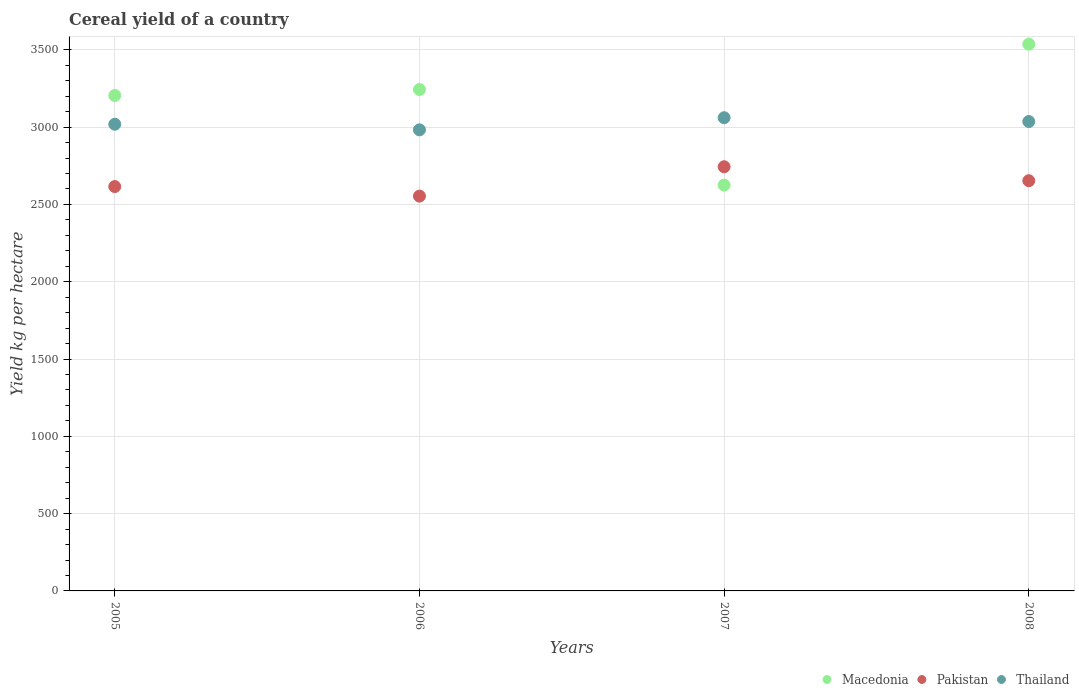How many different coloured dotlines are there?
Offer a very short reply. 3. Is the number of dotlines equal to the number of legend labels?
Provide a succinct answer. Yes. What is the total cereal yield in Thailand in 2008?
Your answer should be very brief. 3036.48. Across all years, what is the maximum total cereal yield in Pakistan?
Make the answer very short. 2743.98. Across all years, what is the minimum total cereal yield in Pakistan?
Provide a short and direct response. 2553.97. In which year was the total cereal yield in Thailand minimum?
Offer a terse response. 2006. What is the total total cereal yield in Macedonia in the graph?
Provide a succinct answer. 1.26e+04. What is the difference between the total cereal yield in Macedonia in 2005 and that in 2007?
Provide a short and direct response. 579.82. What is the difference between the total cereal yield in Pakistan in 2006 and the total cereal yield in Macedonia in 2005?
Provide a succinct answer. -651.06. What is the average total cereal yield in Thailand per year?
Make the answer very short. 3024.8. In the year 2007, what is the difference between the total cereal yield in Macedonia and total cereal yield in Pakistan?
Your response must be concise. -118.77. What is the ratio of the total cereal yield in Macedonia in 2007 to that in 2008?
Your response must be concise. 0.74. Is the total cereal yield in Pakistan in 2007 less than that in 2008?
Provide a short and direct response. No. What is the difference between the highest and the second highest total cereal yield in Thailand?
Your response must be concise. 24.66. What is the difference between the highest and the lowest total cereal yield in Pakistan?
Ensure brevity in your answer.  190.01. In how many years, is the total cereal yield in Macedonia greater than the average total cereal yield in Macedonia taken over all years?
Keep it short and to the point. 3. Is it the case that in every year, the sum of the total cereal yield in Pakistan and total cereal yield in Macedonia  is greater than the total cereal yield in Thailand?
Keep it short and to the point. Yes. Does the total cereal yield in Macedonia monotonically increase over the years?
Give a very brief answer. No. Is the total cereal yield in Thailand strictly greater than the total cereal yield in Macedonia over the years?
Your response must be concise. No. How many dotlines are there?
Offer a terse response. 3. How many years are there in the graph?
Keep it short and to the point. 4. What is the difference between two consecutive major ticks on the Y-axis?
Your answer should be compact. 500. Where does the legend appear in the graph?
Your answer should be very brief. Bottom right. How are the legend labels stacked?
Make the answer very short. Horizontal. What is the title of the graph?
Ensure brevity in your answer.  Cereal yield of a country. Does "Nicaragua" appear as one of the legend labels in the graph?
Your response must be concise. No. What is the label or title of the X-axis?
Your answer should be very brief. Years. What is the label or title of the Y-axis?
Make the answer very short. Yield kg per hectare. What is the Yield kg per hectare of Macedonia in 2005?
Offer a terse response. 3205.03. What is the Yield kg per hectare in Pakistan in 2005?
Offer a terse response. 2615.79. What is the Yield kg per hectare in Thailand in 2005?
Your response must be concise. 3018.89. What is the Yield kg per hectare of Macedonia in 2006?
Your answer should be very brief. 3243.51. What is the Yield kg per hectare of Pakistan in 2006?
Provide a short and direct response. 2553.97. What is the Yield kg per hectare in Thailand in 2006?
Make the answer very short. 2982.71. What is the Yield kg per hectare of Macedonia in 2007?
Provide a short and direct response. 2625.21. What is the Yield kg per hectare of Pakistan in 2007?
Your response must be concise. 2743.98. What is the Yield kg per hectare of Thailand in 2007?
Give a very brief answer. 3061.14. What is the Yield kg per hectare of Macedonia in 2008?
Your answer should be compact. 3536.86. What is the Yield kg per hectare in Pakistan in 2008?
Offer a very short reply. 2653.72. What is the Yield kg per hectare in Thailand in 2008?
Ensure brevity in your answer.  3036.48. Across all years, what is the maximum Yield kg per hectare of Macedonia?
Provide a short and direct response. 3536.86. Across all years, what is the maximum Yield kg per hectare of Pakistan?
Make the answer very short. 2743.98. Across all years, what is the maximum Yield kg per hectare of Thailand?
Give a very brief answer. 3061.14. Across all years, what is the minimum Yield kg per hectare in Macedonia?
Give a very brief answer. 2625.21. Across all years, what is the minimum Yield kg per hectare in Pakistan?
Keep it short and to the point. 2553.97. Across all years, what is the minimum Yield kg per hectare in Thailand?
Your answer should be very brief. 2982.71. What is the total Yield kg per hectare in Macedonia in the graph?
Give a very brief answer. 1.26e+04. What is the total Yield kg per hectare in Pakistan in the graph?
Your answer should be compact. 1.06e+04. What is the total Yield kg per hectare in Thailand in the graph?
Offer a terse response. 1.21e+04. What is the difference between the Yield kg per hectare of Macedonia in 2005 and that in 2006?
Your answer should be very brief. -38.48. What is the difference between the Yield kg per hectare of Pakistan in 2005 and that in 2006?
Keep it short and to the point. 61.83. What is the difference between the Yield kg per hectare of Thailand in 2005 and that in 2006?
Your answer should be compact. 36.18. What is the difference between the Yield kg per hectare in Macedonia in 2005 and that in 2007?
Provide a short and direct response. 579.82. What is the difference between the Yield kg per hectare of Pakistan in 2005 and that in 2007?
Make the answer very short. -128.19. What is the difference between the Yield kg per hectare of Thailand in 2005 and that in 2007?
Ensure brevity in your answer.  -42.24. What is the difference between the Yield kg per hectare of Macedonia in 2005 and that in 2008?
Provide a short and direct response. -331.83. What is the difference between the Yield kg per hectare of Pakistan in 2005 and that in 2008?
Ensure brevity in your answer.  -37.93. What is the difference between the Yield kg per hectare of Thailand in 2005 and that in 2008?
Make the answer very short. -17.59. What is the difference between the Yield kg per hectare in Macedonia in 2006 and that in 2007?
Offer a very short reply. 618.3. What is the difference between the Yield kg per hectare of Pakistan in 2006 and that in 2007?
Your response must be concise. -190.01. What is the difference between the Yield kg per hectare of Thailand in 2006 and that in 2007?
Offer a very short reply. -78.42. What is the difference between the Yield kg per hectare of Macedonia in 2006 and that in 2008?
Make the answer very short. -293.35. What is the difference between the Yield kg per hectare of Pakistan in 2006 and that in 2008?
Offer a terse response. -99.76. What is the difference between the Yield kg per hectare of Thailand in 2006 and that in 2008?
Provide a short and direct response. -53.77. What is the difference between the Yield kg per hectare of Macedonia in 2007 and that in 2008?
Your response must be concise. -911.65. What is the difference between the Yield kg per hectare of Pakistan in 2007 and that in 2008?
Make the answer very short. 90.26. What is the difference between the Yield kg per hectare in Thailand in 2007 and that in 2008?
Offer a very short reply. 24.66. What is the difference between the Yield kg per hectare in Macedonia in 2005 and the Yield kg per hectare in Pakistan in 2006?
Your answer should be compact. 651.06. What is the difference between the Yield kg per hectare in Macedonia in 2005 and the Yield kg per hectare in Thailand in 2006?
Make the answer very short. 222.31. What is the difference between the Yield kg per hectare in Pakistan in 2005 and the Yield kg per hectare in Thailand in 2006?
Provide a succinct answer. -366.92. What is the difference between the Yield kg per hectare of Macedonia in 2005 and the Yield kg per hectare of Pakistan in 2007?
Your response must be concise. 461.05. What is the difference between the Yield kg per hectare of Macedonia in 2005 and the Yield kg per hectare of Thailand in 2007?
Make the answer very short. 143.89. What is the difference between the Yield kg per hectare of Pakistan in 2005 and the Yield kg per hectare of Thailand in 2007?
Offer a very short reply. -445.34. What is the difference between the Yield kg per hectare in Macedonia in 2005 and the Yield kg per hectare in Pakistan in 2008?
Give a very brief answer. 551.3. What is the difference between the Yield kg per hectare in Macedonia in 2005 and the Yield kg per hectare in Thailand in 2008?
Provide a short and direct response. 168.55. What is the difference between the Yield kg per hectare in Pakistan in 2005 and the Yield kg per hectare in Thailand in 2008?
Give a very brief answer. -420.68. What is the difference between the Yield kg per hectare of Macedonia in 2006 and the Yield kg per hectare of Pakistan in 2007?
Your answer should be very brief. 499.53. What is the difference between the Yield kg per hectare of Macedonia in 2006 and the Yield kg per hectare of Thailand in 2007?
Offer a very short reply. 182.38. What is the difference between the Yield kg per hectare of Pakistan in 2006 and the Yield kg per hectare of Thailand in 2007?
Your response must be concise. -507.17. What is the difference between the Yield kg per hectare in Macedonia in 2006 and the Yield kg per hectare in Pakistan in 2008?
Make the answer very short. 589.79. What is the difference between the Yield kg per hectare in Macedonia in 2006 and the Yield kg per hectare in Thailand in 2008?
Your answer should be compact. 207.03. What is the difference between the Yield kg per hectare in Pakistan in 2006 and the Yield kg per hectare in Thailand in 2008?
Your response must be concise. -482.51. What is the difference between the Yield kg per hectare in Macedonia in 2007 and the Yield kg per hectare in Pakistan in 2008?
Offer a very short reply. -28.52. What is the difference between the Yield kg per hectare of Macedonia in 2007 and the Yield kg per hectare of Thailand in 2008?
Offer a very short reply. -411.27. What is the difference between the Yield kg per hectare in Pakistan in 2007 and the Yield kg per hectare in Thailand in 2008?
Keep it short and to the point. -292.5. What is the average Yield kg per hectare of Macedonia per year?
Offer a terse response. 3152.65. What is the average Yield kg per hectare in Pakistan per year?
Keep it short and to the point. 2641.87. What is the average Yield kg per hectare of Thailand per year?
Offer a very short reply. 3024.8. In the year 2005, what is the difference between the Yield kg per hectare in Macedonia and Yield kg per hectare in Pakistan?
Make the answer very short. 589.23. In the year 2005, what is the difference between the Yield kg per hectare in Macedonia and Yield kg per hectare in Thailand?
Provide a short and direct response. 186.13. In the year 2005, what is the difference between the Yield kg per hectare of Pakistan and Yield kg per hectare of Thailand?
Offer a very short reply. -403.1. In the year 2006, what is the difference between the Yield kg per hectare of Macedonia and Yield kg per hectare of Pakistan?
Provide a short and direct response. 689.54. In the year 2006, what is the difference between the Yield kg per hectare in Macedonia and Yield kg per hectare in Thailand?
Provide a succinct answer. 260.8. In the year 2006, what is the difference between the Yield kg per hectare in Pakistan and Yield kg per hectare in Thailand?
Give a very brief answer. -428.75. In the year 2007, what is the difference between the Yield kg per hectare of Macedonia and Yield kg per hectare of Pakistan?
Provide a succinct answer. -118.77. In the year 2007, what is the difference between the Yield kg per hectare of Macedonia and Yield kg per hectare of Thailand?
Provide a succinct answer. -435.93. In the year 2007, what is the difference between the Yield kg per hectare in Pakistan and Yield kg per hectare in Thailand?
Offer a very short reply. -317.15. In the year 2008, what is the difference between the Yield kg per hectare in Macedonia and Yield kg per hectare in Pakistan?
Your response must be concise. 883.13. In the year 2008, what is the difference between the Yield kg per hectare of Macedonia and Yield kg per hectare of Thailand?
Give a very brief answer. 500.38. In the year 2008, what is the difference between the Yield kg per hectare of Pakistan and Yield kg per hectare of Thailand?
Provide a short and direct response. -382.75. What is the ratio of the Yield kg per hectare in Macedonia in 2005 to that in 2006?
Offer a terse response. 0.99. What is the ratio of the Yield kg per hectare in Pakistan in 2005 to that in 2006?
Make the answer very short. 1.02. What is the ratio of the Yield kg per hectare in Thailand in 2005 to that in 2006?
Make the answer very short. 1.01. What is the ratio of the Yield kg per hectare of Macedonia in 2005 to that in 2007?
Make the answer very short. 1.22. What is the ratio of the Yield kg per hectare of Pakistan in 2005 to that in 2007?
Ensure brevity in your answer.  0.95. What is the ratio of the Yield kg per hectare in Thailand in 2005 to that in 2007?
Offer a terse response. 0.99. What is the ratio of the Yield kg per hectare in Macedonia in 2005 to that in 2008?
Your answer should be very brief. 0.91. What is the ratio of the Yield kg per hectare in Pakistan in 2005 to that in 2008?
Your response must be concise. 0.99. What is the ratio of the Yield kg per hectare of Thailand in 2005 to that in 2008?
Offer a very short reply. 0.99. What is the ratio of the Yield kg per hectare of Macedonia in 2006 to that in 2007?
Provide a short and direct response. 1.24. What is the ratio of the Yield kg per hectare in Pakistan in 2006 to that in 2007?
Provide a short and direct response. 0.93. What is the ratio of the Yield kg per hectare in Thailand in 2006 to that in 2007?
Offer a terse response. 0.97. What is the ratio of the Yield kg per hectare of Macedonia in 2006 to that in 2008?
Ensure brevity in your answer.  0.92. What is the ratio of the Yield kg per hectare in Pakistan in 2006 to that in 2008?
Provide a short and direct response. 0.96. What is the ratio of the Yield kg per hectare in Thailand in 2006 to that in 2008?
Give a very brief answer. 0.98. What is the ratio of the Yield kg per hectare of Macedonia in 2007 to that in 2008?
Make the answer very short. 0.74. What is the ratio of the Yield kg per hectare of Pakistan in 2007 to that in 2008?
Ensure brevity in your answer.  1.03. What is the ratio of the Yield kg per hectare in Thailand in 2007 to that in 2008?
Provide a succinct answer. 1.01. What is the difference between the highest and the second highest Yield kg per hectare of Macedonia?
Provide a succinct answer. 293.35. What is the difference between the highest and the second highest Yield kg per hectare of Pakistan?
Keep it short and to the point. 90.26. What is the difference between the highest and the second highest Yield kg per hectare in Thailand?
Provide a succinct answer. 24.66. What is the difference between the highest and the lowest Yield kg per hectare of Macedonia?
Your answer should be compact. 911.65. What is the difference between the highest and the lowest Yield kg per hectare of Pakistan?
Provide a short and direct response. 190.01. What is the difference between the highest and the lowest Yield kg per hectare of Thailand?
Give a very brief answer. 78.42. 